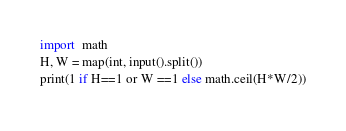Convert code to text. <code><loc_0><loc_0><loc_500><loc_500><_Python_>import  math
H, W = map(int, input().split())
print(1 if H==1 or W ==1 else math.ceil(H*W/2))</code> 